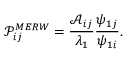<formula> <loc_0><loc_0><loc_500><loc_500>\mathcal { P } _ { i j } ^ { M E R W } = \frac { \mathcal { A } _ { i j } } { \lambda _ { 1 } } \frac { \psi _ { 1 j } } { \psi _ { 1 i } } .</formula> 